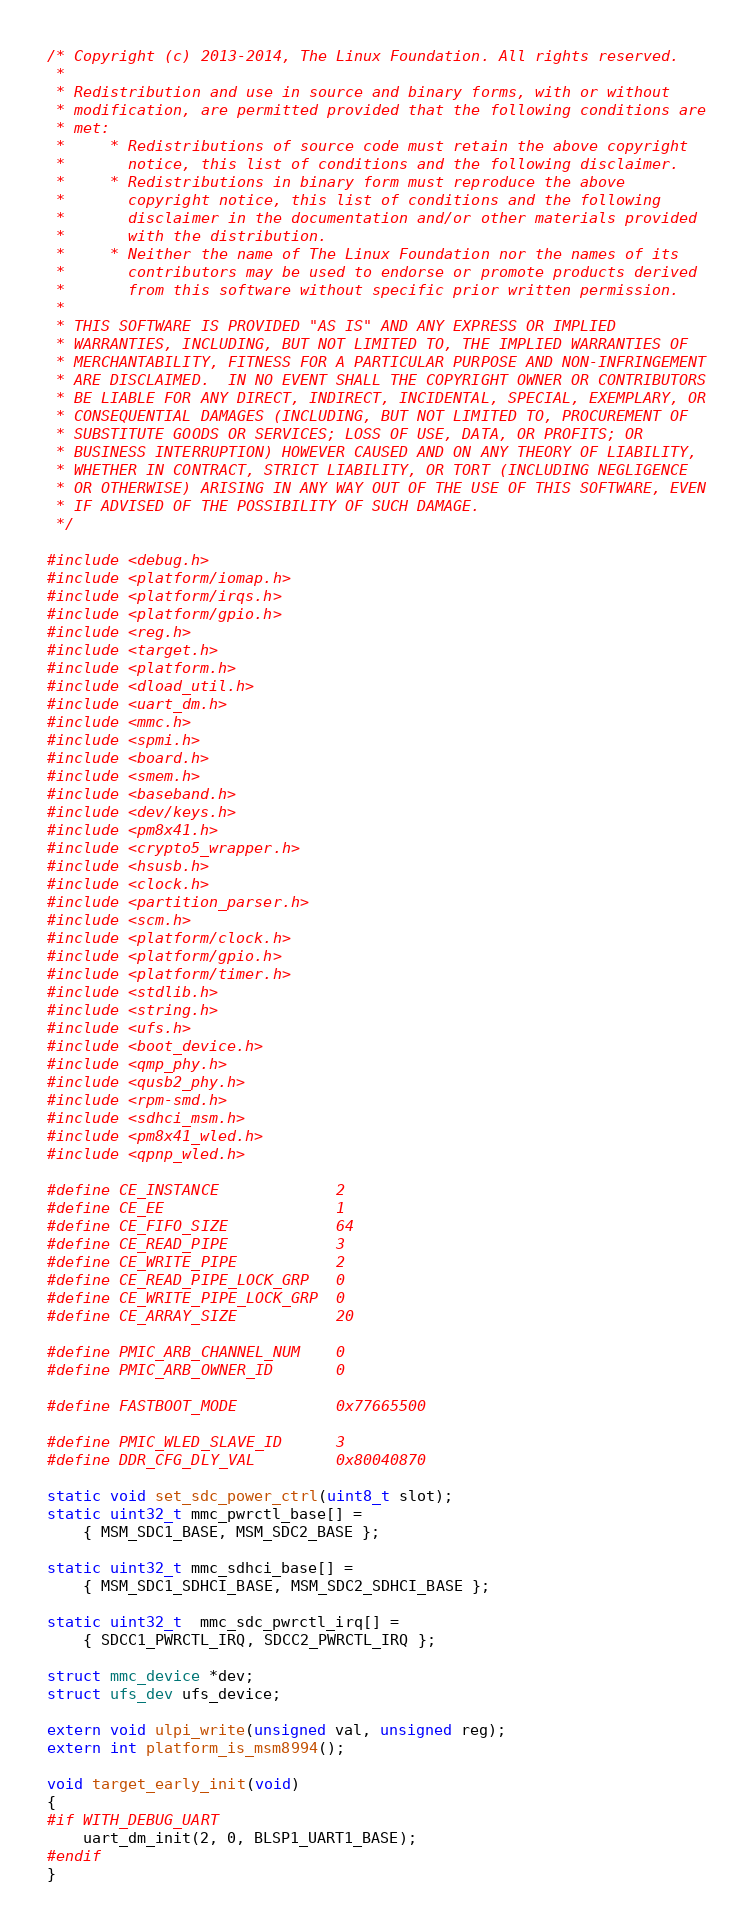<code> <loc_0><loc_0><loc_500><loc_500><_C_>/* Copyright (c) 2013-2014, The Linux Foundation. All rights reserved.
 *
 * Redistribution and use in source and binary forms, with or without
 * modification, are permitted provided that the following conditions are
 * met:
 *     * Redistributions of source code must retain the above copyright
 *       notice, this list of conditions and the following disclaimer.
 *     * Redistributions in binary form must reproduce the above
 *       copyright notice, this list of conditions and the following
 *       disclaimer in the documentation and/or other materials provided
 *       with the distribution.
 *     * Neither the name of The Linux Foundation nor the names of its
 *       contributors may be used to endorse or promote products derived
 *       from this software without specific prior written permission.
 *
 * THIS SOFTWARE IS PROVIDED "AS IS" AND ANY EXPRESS OR IMPLIED
 * WARRANTIES, INCLUDING, BUT NOT LIMITED TO, THE IMPLIED WARRANTIES OF
 * MERCHANTABILITY, FITNESS FOR A PARTICULAR PURPOSE AND NON-INFRINGEMENT
 * ARE DISCLAIMED.  IN NO EVENT SHALL THE COPYRIGHT OWNER OR CONTRIBUTORS
 * BE LIABLE FOR ANY DIRECT, INDIRECT, INCIDENTAL, SPECIAL, EXEMPLARY, OR
 * CONSEQUENTIAL DAMAGES (INCLUDING, BUT NOT LIMITED TO, PROCUREMENT OF
 * SUBSTITUTE GOODS OR SERVICES; LOSS OF USE, DATA, OR PROFITS; OR
 * BUSINESS INTERRUPTION) HOWEVER CAUSED AND ON ANY THEORY OF LIABILITY,
 * WHETHER IN CONTRACT, STRICT LIABILITY, OR TORT (INCLUDING NEGLIGENCE
 * OR OTHERWISE) ARISING IN ANY WAY OUT OF THE USE OF THIS SOFTWARE, EVEN
 * IF ADVISED OF THE POSSIBILITY OF SUCH DAMAGE.
 */

#include <debug.h>
#include <platform/iomap.h>
#include <platform/irqs.h>
#include <platform/gpio.h>
#include <reg.h>
#include <target.h>
#include <platform.h>
#include <dload_util.h>
#include <uart_dm.h>
#include <mmc.h>
#include <spmi.h>
#include <board.h>
#include <smem.h>
#include <baseband.h>
#include <dev/keys.h>
#include <pm8x41.h>
#include <crypto5_wrapper.h>
#include <hsusb.h>
#include <clock.h>
#include <partition_parser.h>
#include <scm.h>
#include <platform/clock.h>
#include <platform/gpio.h>
#include <platform/timer.h>
#include <stdlib.h>
#include <string.h>
#include <ufs.h>
#include <boot_device.h>
#include <qmp_phy.h>
#include <qusb2_phy.h>
#include <rpm-smd.h>
#include <sdhci_msm.h>
#include <pm8x41_wled.h>
#include <qpnp_wled.h>

#define CE_INSTANCE             2
#define CE_EE                   1
#define CE_FIFO_SIZE            64
#define CE_READ_PIPE            3
#define CE_WRITE_PIPE           2
#define CE_READ_PIPE_LOCK_GRP   0
#define CE_WRITE_PIPE_LOCK_GRP  0
#define CE_ARRAY_SIZE           20

#define PMIC_ARB_CHANNEL_NUM    0
#define PMIC_ARB_OWNER_ID       0

#define FASTBOOT_MODE           0x77665500

#define PMIC_WLED_SLAVE_ID      3
#define DDR_CFG_DLY_VAL         0x80040870

static void set_sdc_power_ctrl(uint8_t slot);
static uint32_t mmc_pwrctl_base[] =
	{ MSM_SDC1_BASE, MSM_SDC2_BASE };

static uint32_t mmc_sdhci_base[] =
	{ MSM_SDC1_SDHCI_BASE, MSM_SDC2_SDHCI_BASE };

static uint32_t  mmc_sdc_pwrctl_irq[] =
	{ SDCC1_PWRCTL_IRQ, SDCC2_PWRCTL_IRQ };

struct mmc_device *dev;
struct ufs_dev ufs_device;

extern void ulpi_write(unsigned val, unsigned reg);
extern int platform_is_msm8994();

void target_early_init(void)
{
#if WITH_DEBUG_UART
	uart_dm_init(2, 0, BLSP1_UART1_BASE);
#endif
}
</code> 